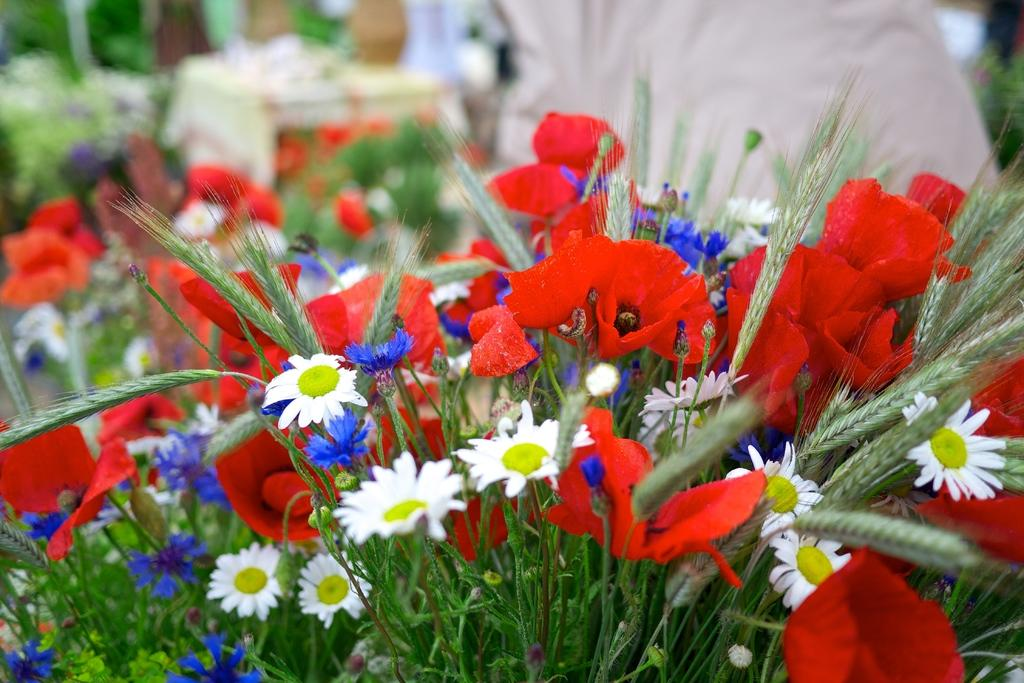What is visible in the foreground of the image? There are flowers and grass in the foreground of the image. What could the flowers and grass in the foreground be? They might be a bouquet. What is visible in the background of the image? There are flowers and plants in the background of the image. Are there any people visible in the background of the image? Yes, there are people in the background of the image. How is the background of the image depicted? The background of the image is blurred. What type of arm is visible in the image? There is no arm visible in the image. Is the sister of the person holding the flowers present in the image? There is no information about a sister or any specific person holding the flowers in the image. 